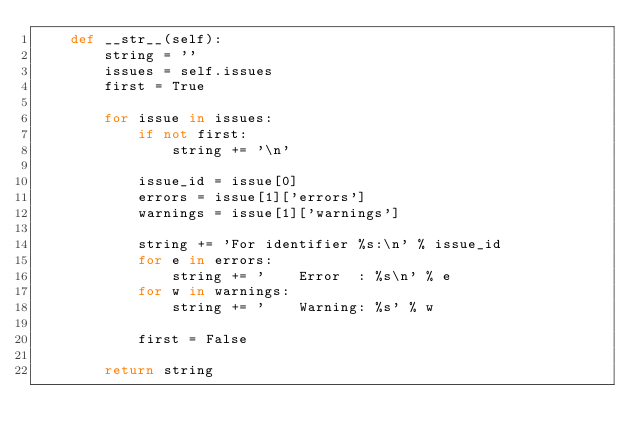Convert code to text. <code><loc_0><loc_0><loc_500><loc_500><_Python_>    def __str__(self):
        string = ''
        issues = self.issues
        first = True

        for issue in issues:
            if not first:
                string += '\n'

            issue_id = issue[0]
            errors = issue[1]['errors']
            warnings = issue[1]['warnings']

            string += 'For identifier %s:\n' % issue_id
            for e in errors:
                string += '    Error  : %s\n' % e
            for w in warnings:
                string += '    Warning: %s' % w

            first = False

        return string
</code> 